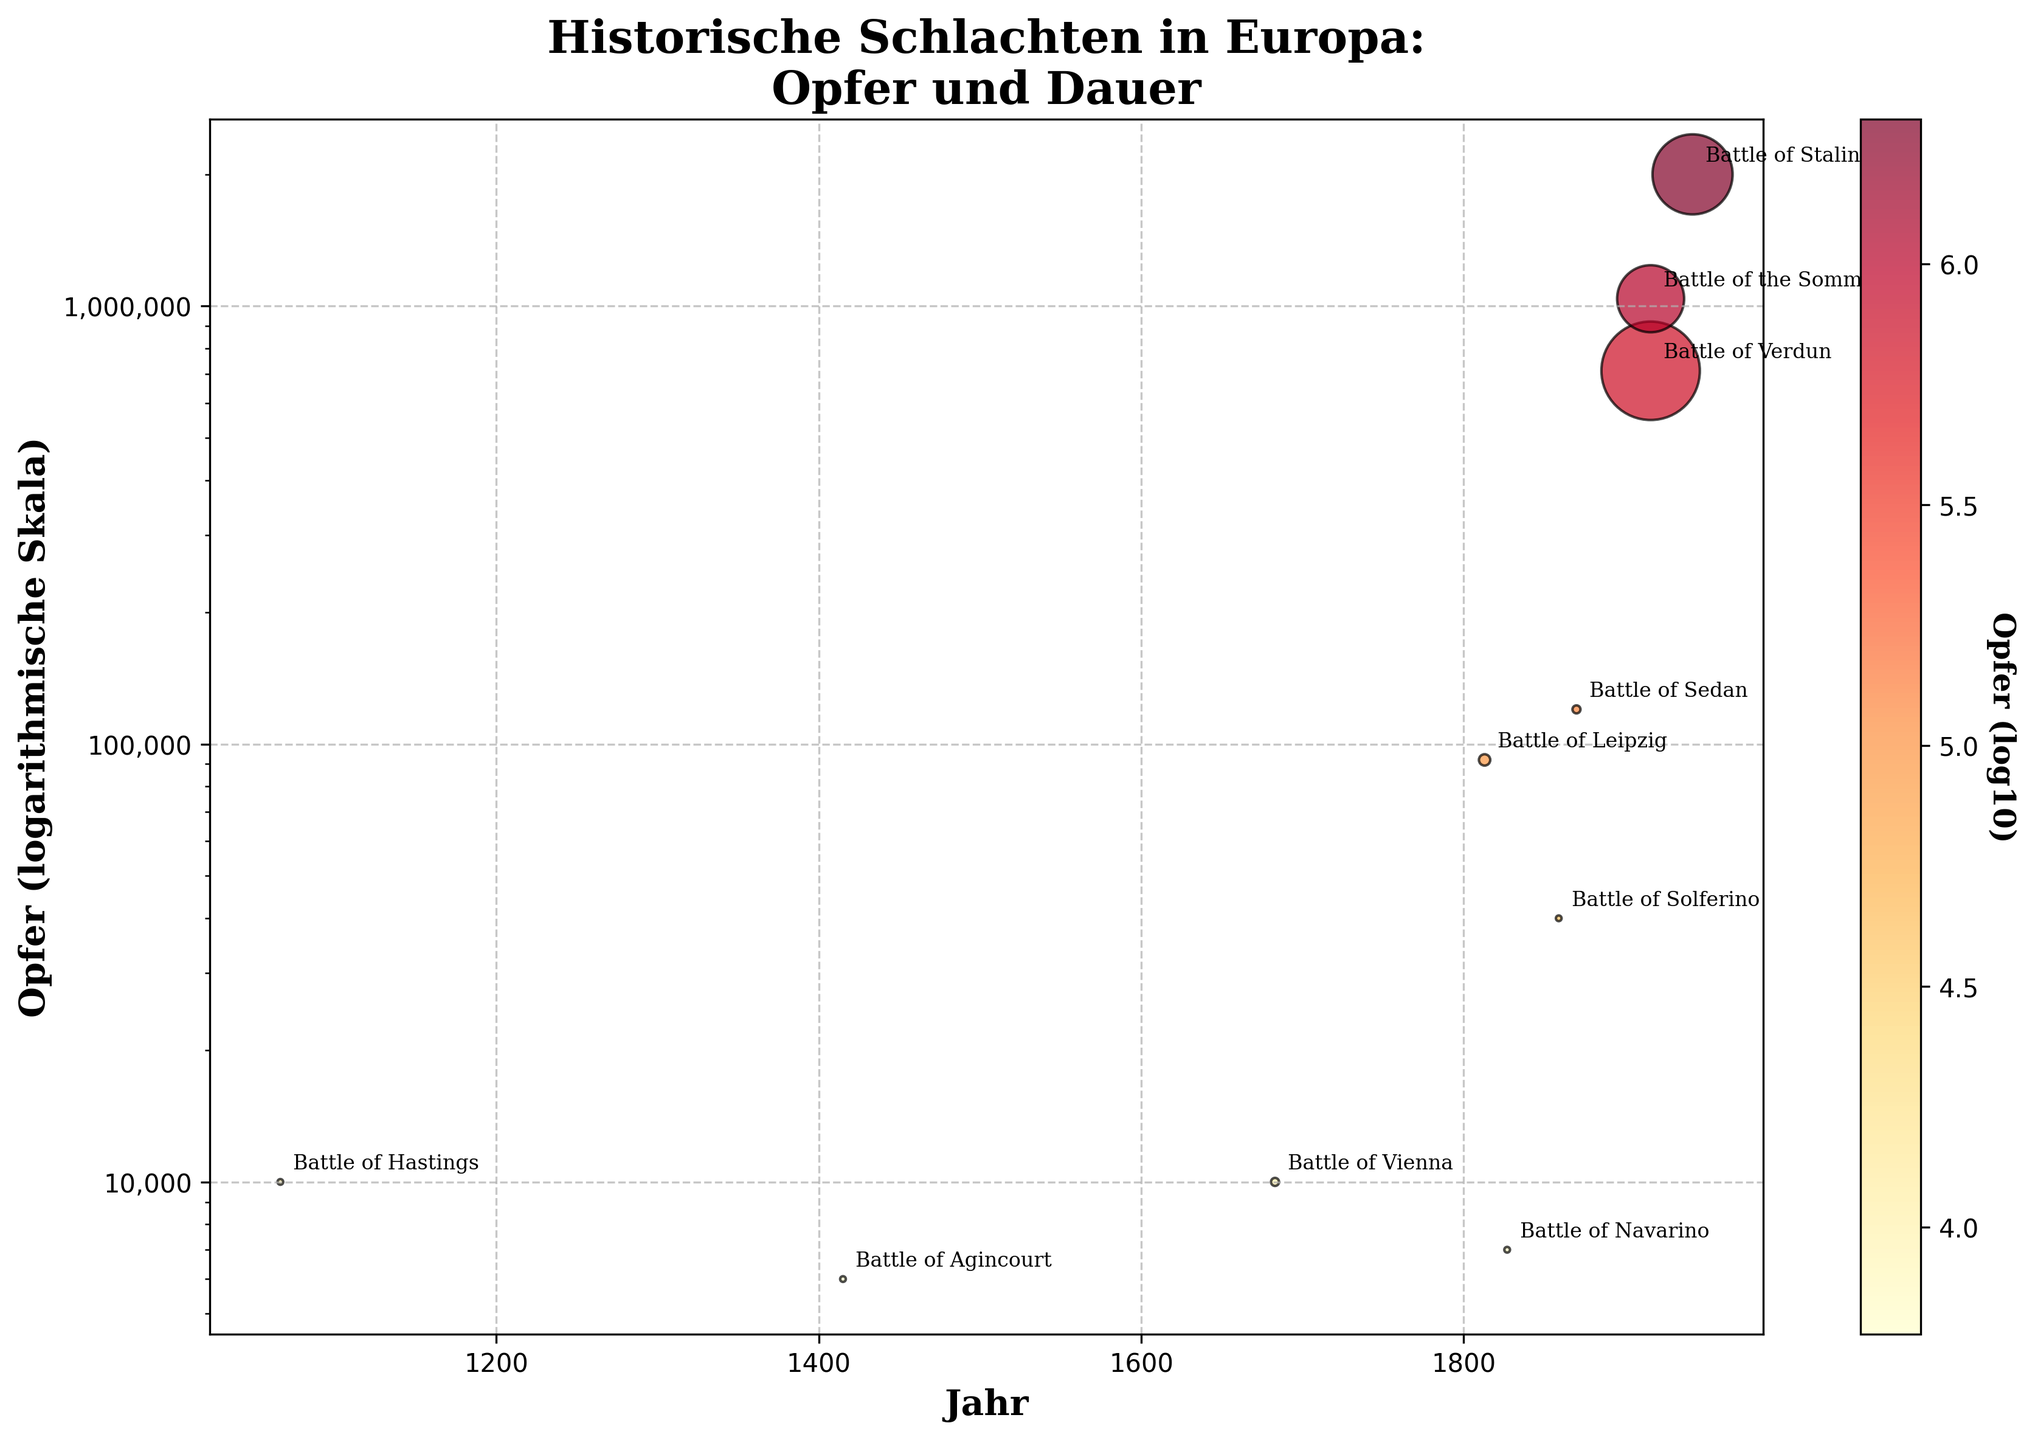What is the title of the figure? The title is usually located at the top of the figure and often describes the main subject or purpose of the graph. In this case, the title is "Historische Schlachten in Europa: Opfer und Dauer"
Answer: Historische Schlachten in Europa: Opfer und Dauer How is the y-axis scaled? The y-axis is scaled logarithmically, which is indicated by the label "Opfer (logarithmische Skala)". This type of scaling is used to manage a wide range of values more effectively.
Answer: Logarithmisch Which battle has the highest number of casualties? To find the battle with the highest number of casualties, look for the highest point on the y-axis (logarithmic scale). From the data points, the Battle of Stalingrad is the highest.
Answer: Battle of Stalingrad What does the size of the data points represent? The size of the data points represents the duration of each battle in days. As indicated in the setup, the duration is multiplied by 5 for visibility.
Answer: Duration in days Compare the casualties of the Battle of Verdun and the Battle of the Somme. Which one is higher? To compare, locate the data points for both battles on the y-axis. The Battle of the Somme has higher casualties at 1,040,000 compared to the Battle of Verdun at 712,000.
Answer: Battle of the Somme Which battle had the shortest duration and how many casualties were there in that battle? The shortest duration is represented by the smallest size of the data points. The Battle of Hastings, Battle of Agincourt, and Battle of Navarino all lasted 1 day, but the Battle of Hastings had 10,000 casualties.
Answer: Battle of Hastings, 10,000 casualties How many battles had a duration of more than 100 days? Identify and count the data points with sizes larger than the average size for 100 days. The Battle of Verdun, the Battle of the Somme, and the Battle of Stalingrad fit this criterion.
Answer: 3 battles Which battle is represented by the smallest data point on the plot? The smallest data points represent battles of shortest duration. Battle with the smallest size is Battle of Hastings, Battle of Agincourt, and Battle of Navarino but among these, Battle of Agincourt has the smallest casualties.
Answer: Battle of Agincourt Calculate the average number of casualties for battles before the 20th century. Sum the casualties for battles before 1900: Battle of Hastings (10000), Battle of Agincourt (6000), Battle of Vienna (10000), Battle of Leipzig (92000), Battle of Navarino (7000), Battle of Solferino (40000), Battle of Sedan (120000). Total casualties are 283,000 over seven battles. Average is 283,000/7 = 40,428.57.
Answer: 40,428.57 Which two battles occurred in the same year and how do their casualties compare? According to the data, the Battle of Verdun and the Battle of the Somme both occurred in 1916. The Battle of the Somme had 1,040,000 casualties, which is higher than the Battle of Verdun with 712,000 casualties.
Answer: Battle of Verdun and the Battle of the Somme; Battle of the Somme has higher casualties 